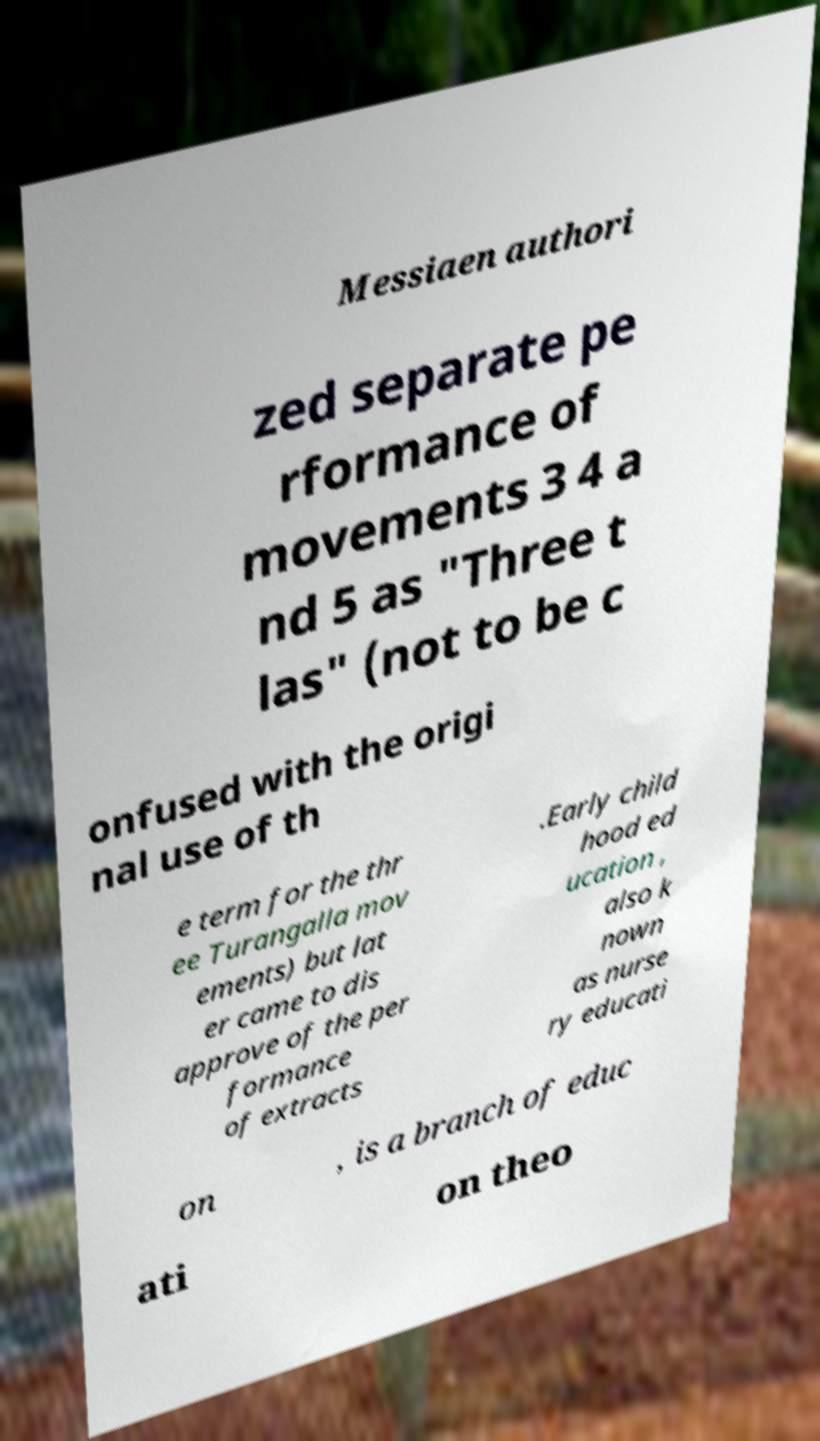I need the written content from this picture converted into text. Can you do that? Messiaen authori zed separate pe rformance of movements 3 4 a nd 5 as "Three t las" (not to be c onfused with the origi nal use of th e term for the thr ee Turangalla mov ements) but lat er came to dis approve of the per formance of extracts .Early child hood ed ucation , also k nown as nurse ry educati on , is a branch of educ ati on theo 